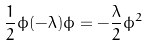<formula> <loc_0><loc_0><loc_500><loc_500>\frac { 1 } { 2 } \phi ( - \lambda ) \phi = - \frac { \lambda } { 2 } \phi ^ { 2 }</formula> 